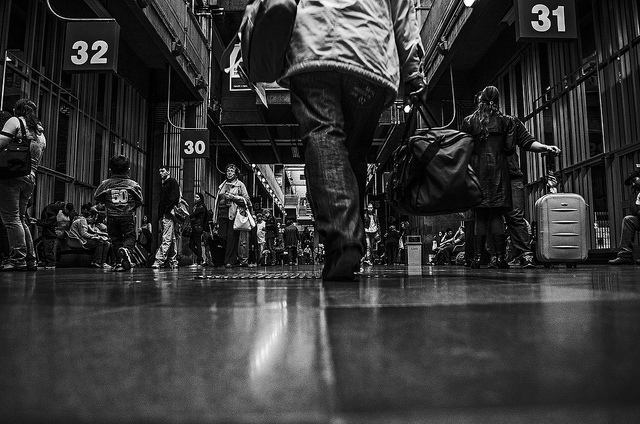<image>What number is he? It's ambiguous to clearly identify the number. It could be '30', '31', '32' or '50'. What number is he? I don't know what number he is. It can be any number between 29 and 50. 